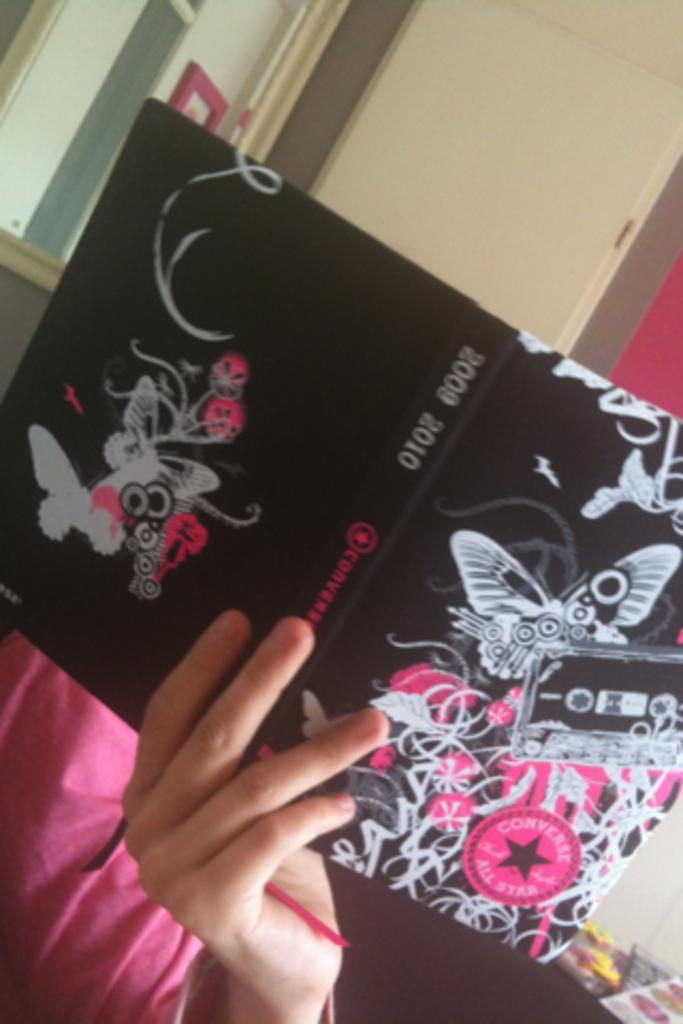What is the person in the image doing? The person in the image is holding a book. Can you describe the book the person is holding? The book has a design on it. What is located on the left side of the image? There is a mirror on the left side of the image. What can be seen in the background of the image? There is a wall in the background of the image. What time of day is it in the image, based on the person's tongue? There is no information about the person's tongue in the image, so it cannot be used to determine the time of day. 